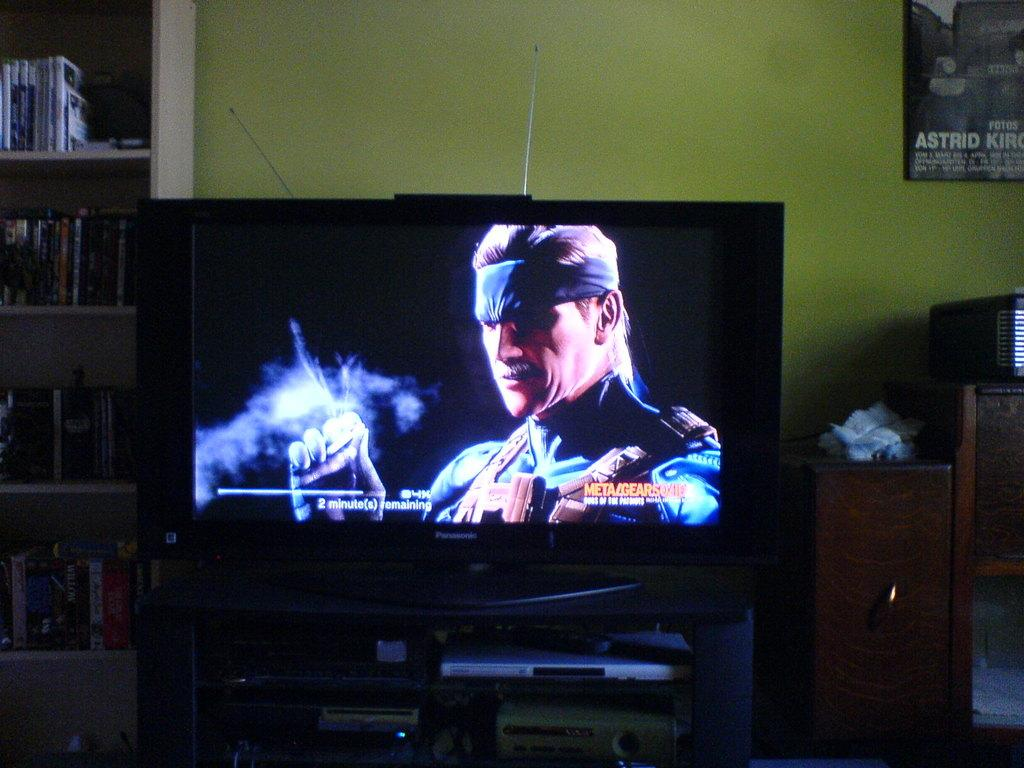<image>
Create a compact narrative representing the image presented. A tv screen shows 2 minutes remaining while a game loads. 